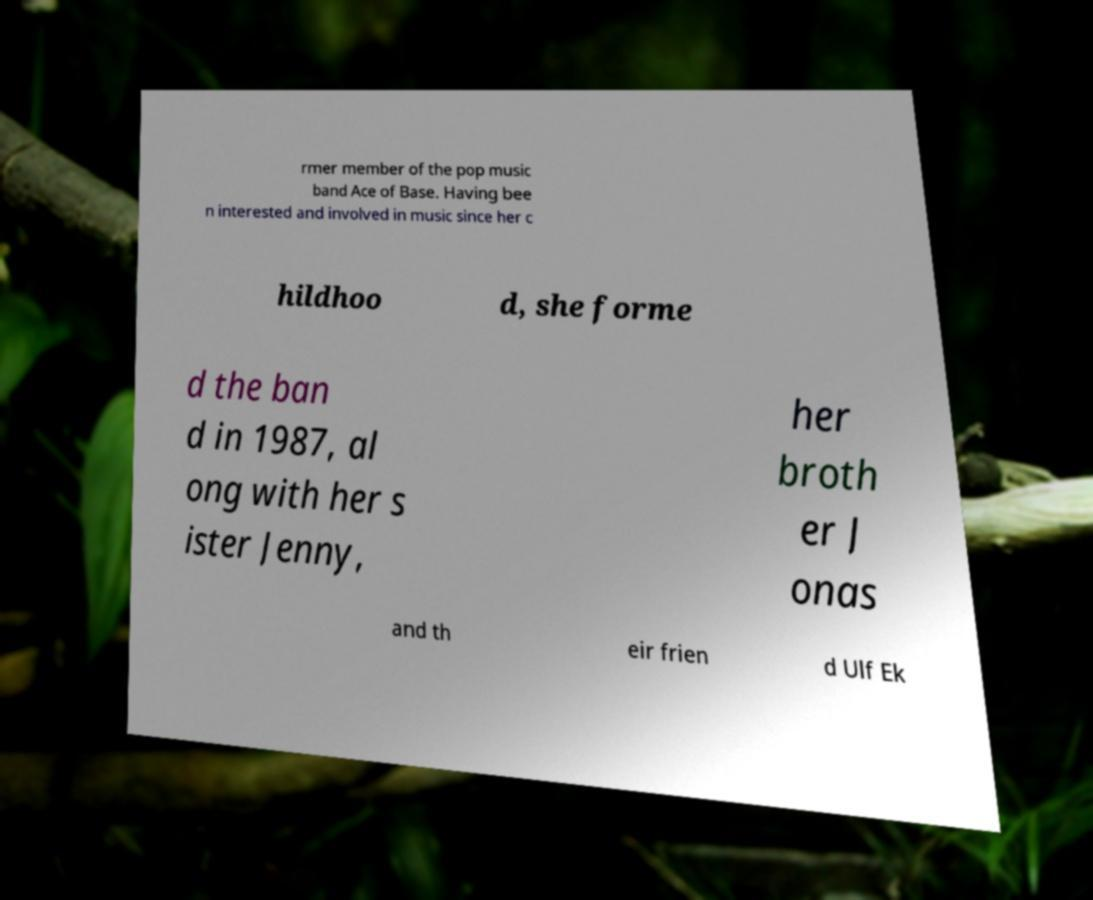I need the written content from this picture converted into text. Can you do that? rmer member of the pop music band Ace of Base. Having bee n interested and involved in music since her c hildhoo d, she forme d the ban d in 1987, al ong with her s ister Jenny, her broth er J onas and th eir frien d Ulf Ek 